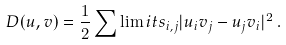Convert formula to latex. <formula><loc_0><loc_0><loc_500><loc_500>D ( u , v ) = \frac { 1 } { 2 } \sum \lim i t s _ { i , j } | u _ { i } v _ { j } - u _ { j } v _ { i } | ^ { 2 } \, .</formula> 